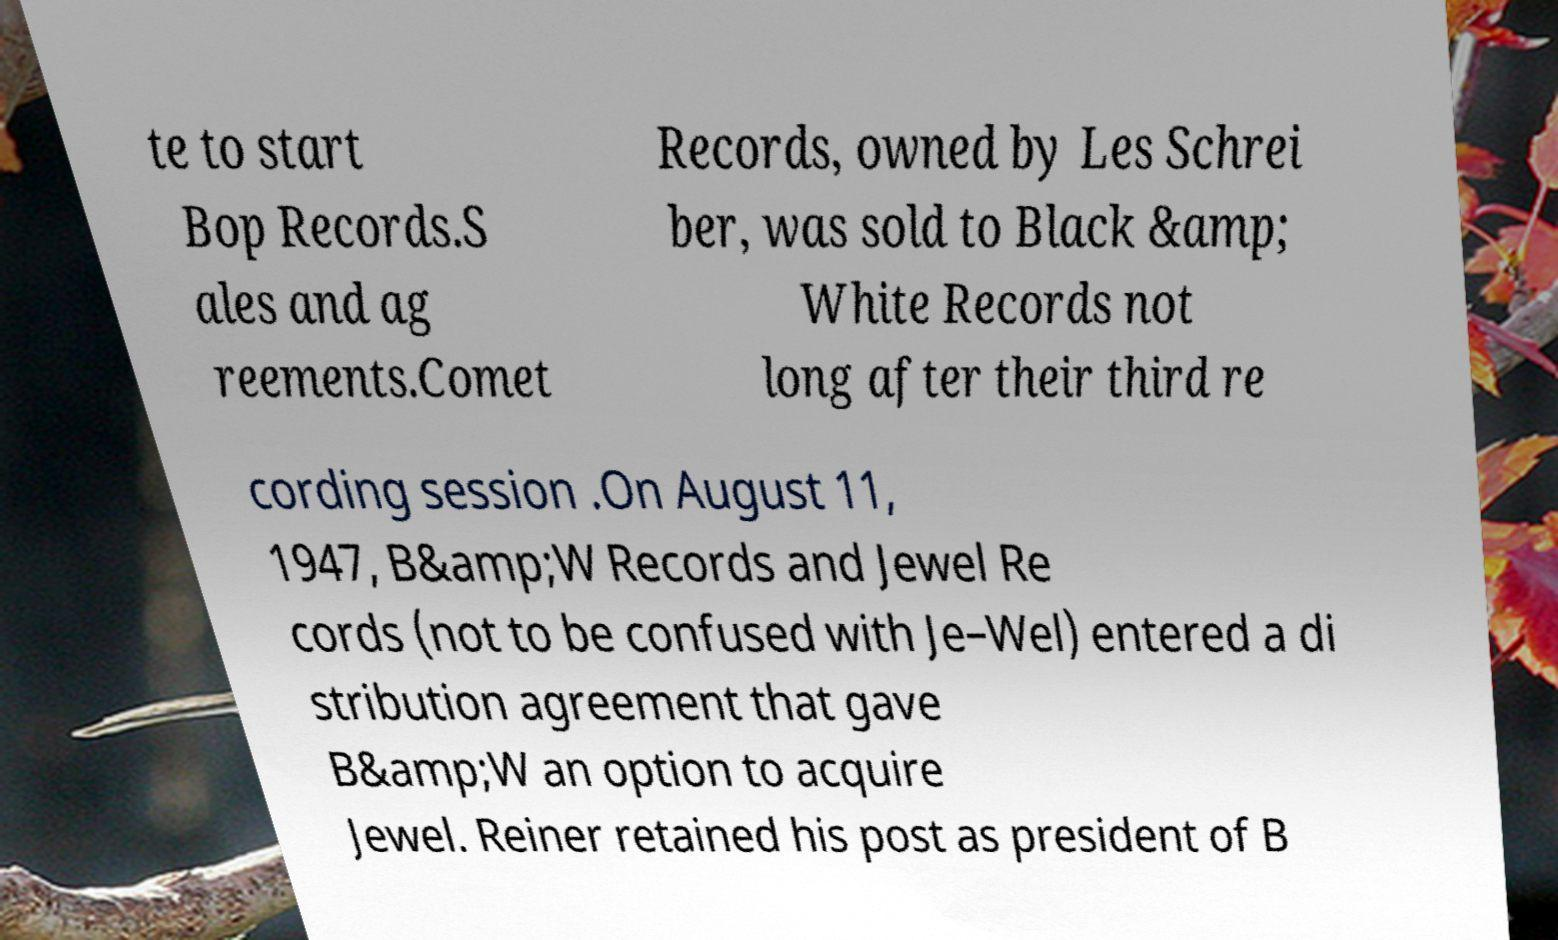Please identify and transcribe the text found in this image. te to start Bop Records.S ales and ag reements.Comet Records, owned by Les Schrei ber, was sold to Black &amp; White Records not long after their third re cording session .On August 11, 1947, B&amp;W Records and Jewel Re cords (not to be confused with Je–Wel) entered a di stribution agreement that gave B&amp;W an option to acquire Jewel. Reiner retained his post as president of B 